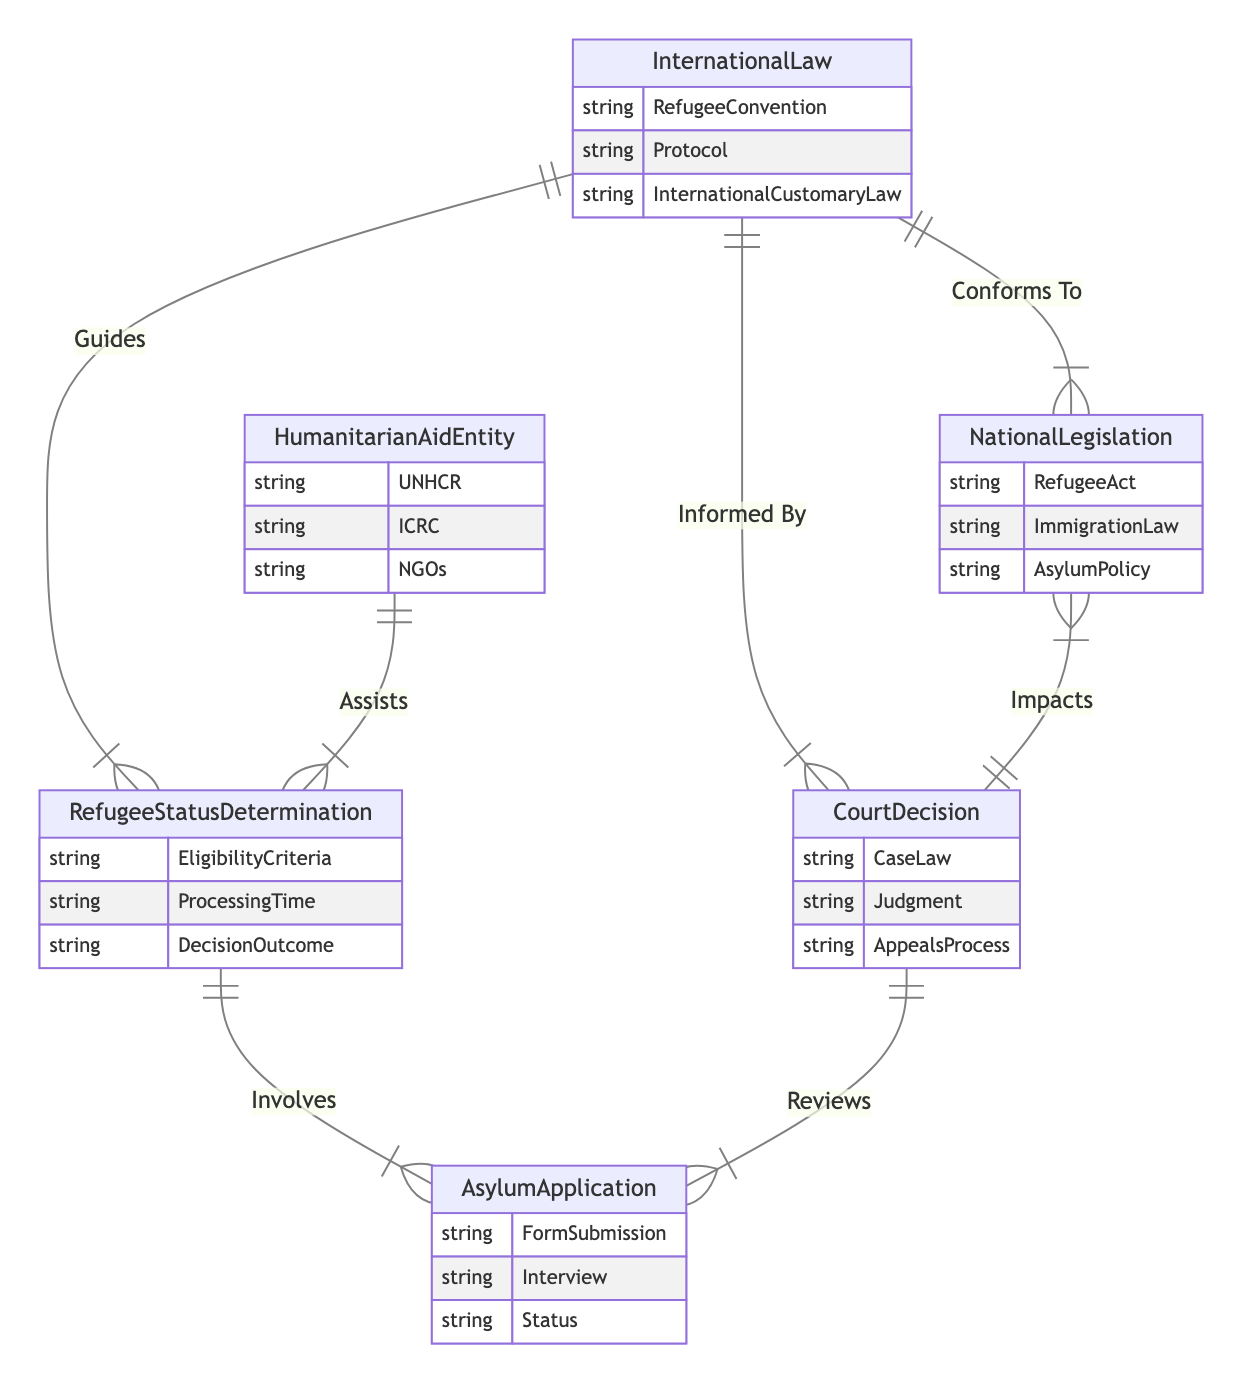What's the total number of entities in the diagram? The diagram lists six entities: InternationalLaw, NationalLegislation, HumanitarianAidEntity, RefugeeStatusDetermination, CourtDecision, and AsylumApplication. Therefore, the total number of entities is 6.
Answer: 6 What relationship connects NationalLegislation and InternationalLaw? The relationship connecting NationalLegislation and InternationalLaw is labeled "Conforms To." This indicates that national legislation is aligned or compliant with international law standards.
Answer: Conforms To Which entity assists RefugeeStatusDetermination? The entity that assists RefugeeStatusDetermination is HumanitarianAidEntity, as denoted by the relationship labeled "Assists." This means that humanitarian aid organizations support the processes involved in determining refugee status.
Answer: HumanitarianAidEntity How many attributes does CourtDecision have? CourtDecision has three attributes: CaseLaw, Judgment, and AppealsProcess. This information indicates the legal elements captured within the court's decisions regarding asylum applications.
Answer: 3 What is the outcome of the relationship between CourtDecision and NationalLegislation? The relationship between CourtDecision and NationalLegislation is labeled "Impacts," showing that decisions made in court can influence or affect national laws. This indicates the reciprocal nature of the legal process where court rulings can lead to changes in legislation.
Answer: Impacts Which two entities does the relationship "Involves" connect? The relationship "Involves" connects AsylumApplication and RefugeeStatusDetermination, highlighting that the application process for asylum is a part of the determination of refugee status. This illustrates the procedural flow in the legal framework for refugees.
Answer: AsylumApplication, RefugeeStatusDetermination How does InternationalLaw guide the process of RefugeeStatusDetermination? InternationalLaw serves as a guiding framework for RefugeeStatusDetermination as shown by the "Guides" relationship. This indicates that decisions made in determining refugee status are informed by international legal standards and conventions.
Answer: Guides What does the relationship "Reviews" indicate about CourtDecision and AsylumApplication? The "Reviews" relationship indicates that CourtDecision examines or assesses AsylumApplication, implying that court decisions can evaluate the legality or appropriateness of asylum claims. This reflects the judicial oversight aspect of refugee protection.
Answer: Reviews Which entity is informed by CourtDecision? According to the relationship "Informed By," the entity informed by CourtDecision is InternationalLaw. This signifies that legal rulings in courts can influence interpretations and understandings of international law concerning refugees.
Answer: InternationalLaw 